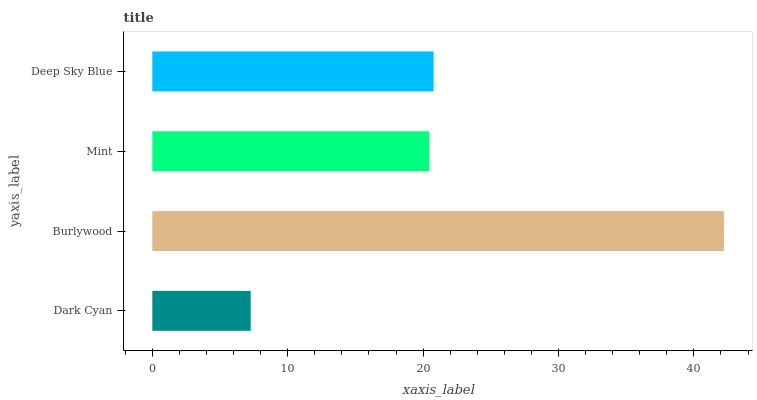Is Dark Cyan the minimum?
Answer yes or no. Yes. Is Burlywood the maximum?
Answer yes or no. Yes. Is Mint the minimum?
Answer yes or no. No. Is Mint the maximum?
Answer yes or no. No. Is Burlywood greater than Mint?
Answer yes or no. Yes. Is Mint less than Burlywood?
Answer yes or no. Yes. Is Mint greater than Burlywood?
Answer yes or no. No. Is Burlywood less than Mint?
Answer yes or no. No. Is Deep Sky Blue the high median?
Answer yes or no. Yes. Is Mint the low median?
Answer yes or no. Yes. Is Dark Cyan the high median?
Answer yes or no. No. Is Dark Cyan the low median?
Answer yes or no. No. 